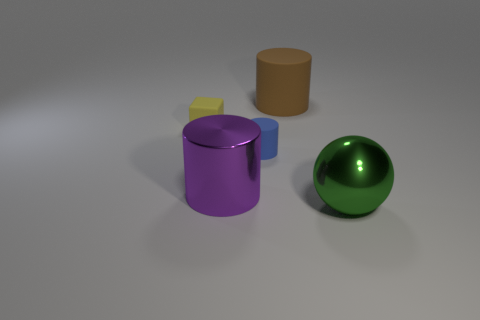There is a large thing behind the small matte thing on the left side of the large metal object that is behind the green sphere; what shape is it?
Provide a short and direct response. Cylinder. What number of objects are large cylinders that are behind the purple cylinder or large cylinders on the left side of the large rubber cylinder?
Your answer should be compact. 2. Do the cube and the cylinder behind the tiny yellow block have the same size?
Offer a terse response. No. Is the cylinder that is behind the small rubber block made of the same material as the large cylinder left of the blue thing?
Provide a succinct answer. No. Are there the same number of yellow things that are in front of the brown rubber thing and small matte cylinders that are on the left side of the big purple shiny object?
Provide a succinct answer. No. How many tiny cylinders have the same color as the shiny ball?
Provide a succinct answer. 0. How many shiny objects are large purple cylinders or large things?
Your response must be concise. 2. There is a green thing in front of the small blue rubber thing; is its shape the same as the big metallic object that is left of the brown matte cylinder?
Your answer should be compact. No. There is a yellow object; how many small cubes are right of it?
Keep it short and to the point. 0. Is there a tiny green thing made of the same material as the yellow object?
Offer a terse response. No. 